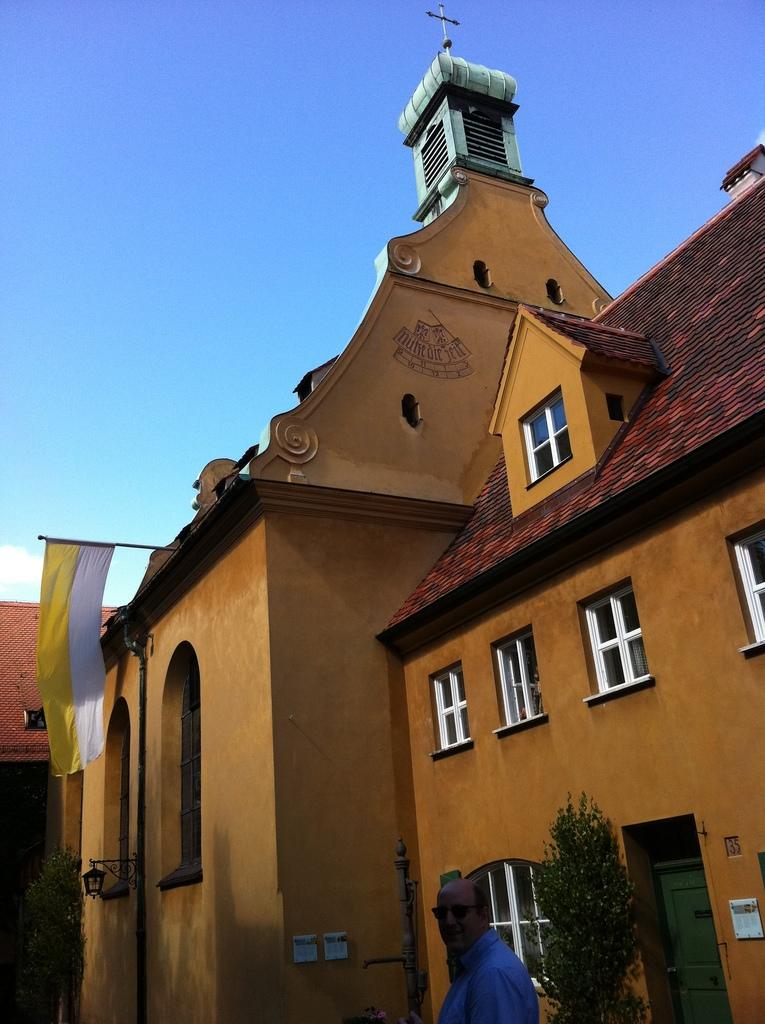What is the main structure in the image? There is a big building in the image. What is on top of the building? The building has a cross on top. What can be seen on the roof of the building? There is a flag hanging on the roof of the building. What is happening in front of the building? There is a person walking on the road in front of the building. What is present between the person and the building? There is a tree in front of the person. What is the secretary doing in the image? There is no secretary present in the image. What is the purpose of the rice in the image? There is no rice present in the image. 